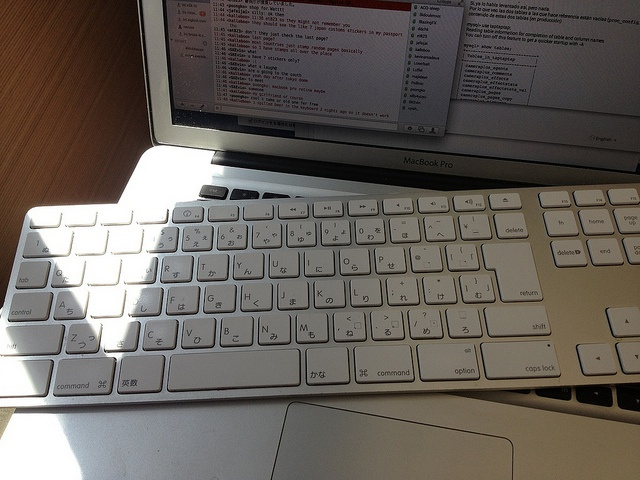Describe the objects in this image and their specific colors. I can see laptop in maroon, gray, black, darkgray, and white tones and keyboard in maroon, gray, white, and black tones in this image. 